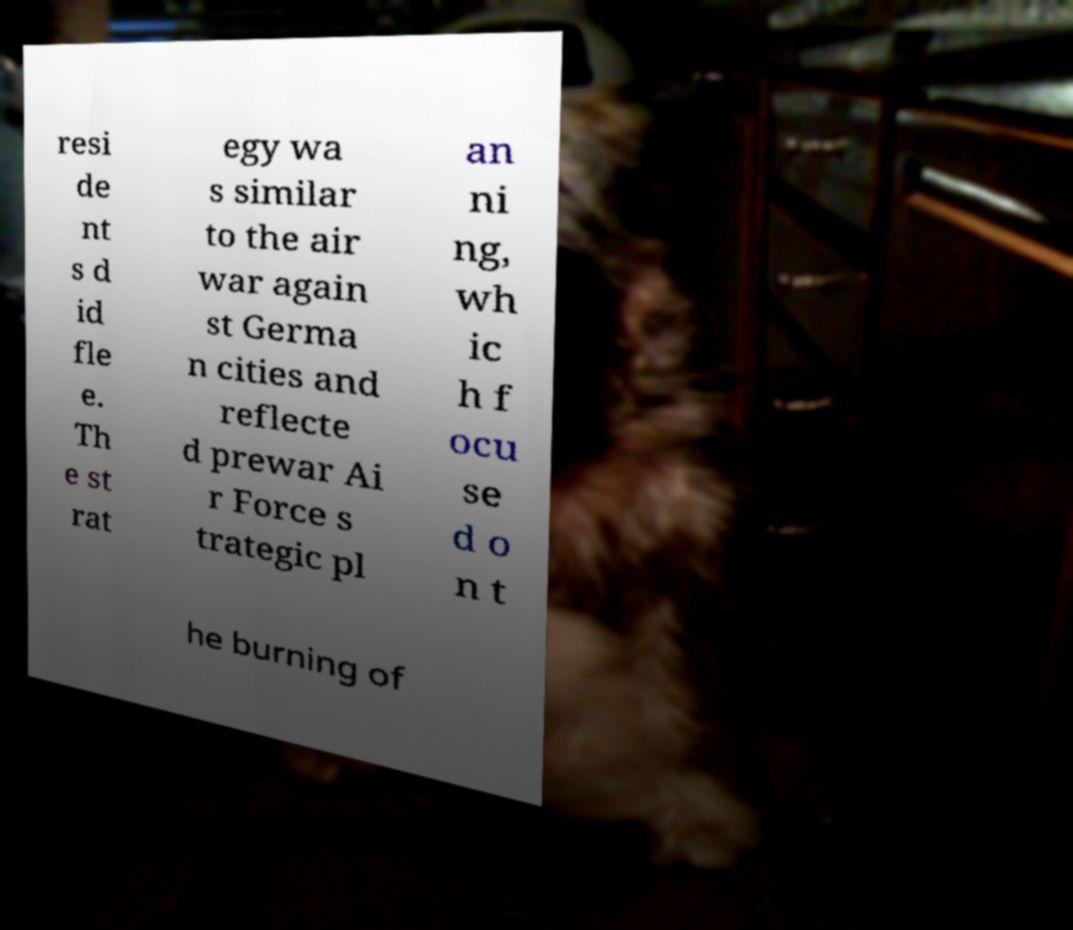For documentation purposes, I need the text within this image transcribed. Could you provide that? resi de nt s d id fle e. Th e st rat egy wa s similar to the air war again st Germa n cities and reflecte d prewar Ai r Force s trategic pl an ni ng, wh ic h f ocu se d o n t he burning of 